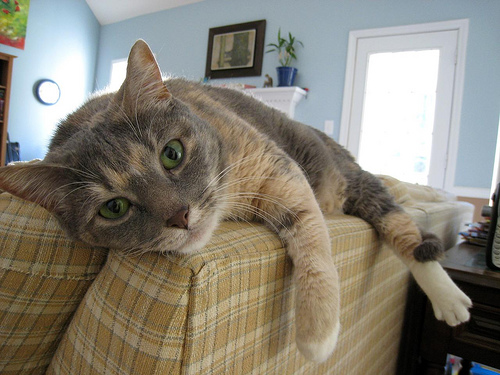How many cats are there? 1 